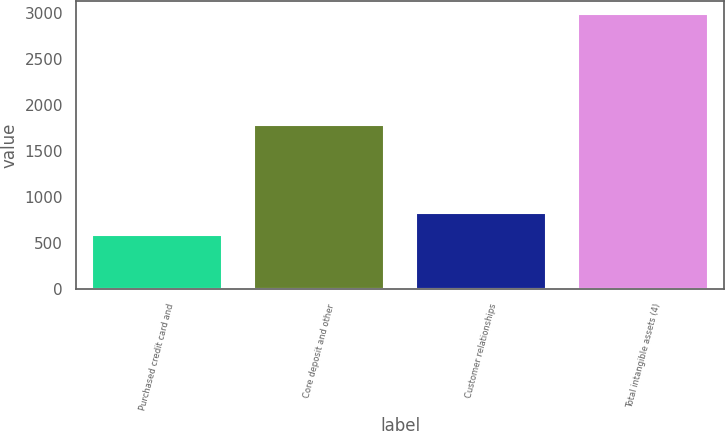<chart> <loc_0><loc_0><loc_500><loc_500><bar_chart><fcel>Purchased credit card and<fcel>Core deposit and other<fcel>Customer relationships<fcel>Total intangible assets (4)<nl><fcel>587<fcel>1790<fcel>827.2<fcel>2989<nl></chart> 